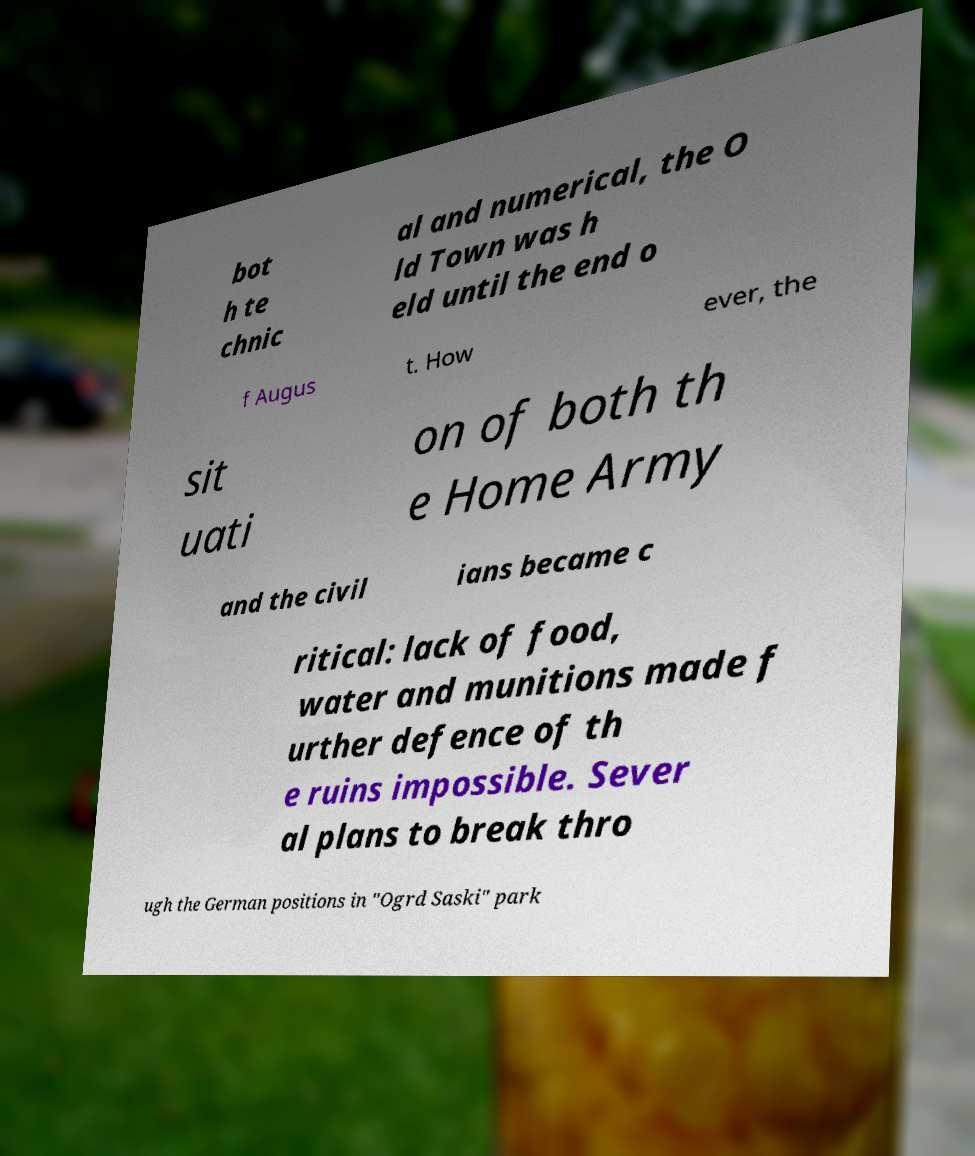What messages or text are displayed in this image? I need them in a readable, typed format. bot h te chnic al and numerical, the O ld Town was h eld until the end o f Augus t. How ever, the sit uati on of both th e Home Army and the civil ians became c ritical: lack of food, water and munitions made f urther defence of th e ruins impossible. Sever al plans to break thro ugh the German positions in "Ogrd Saski" park 